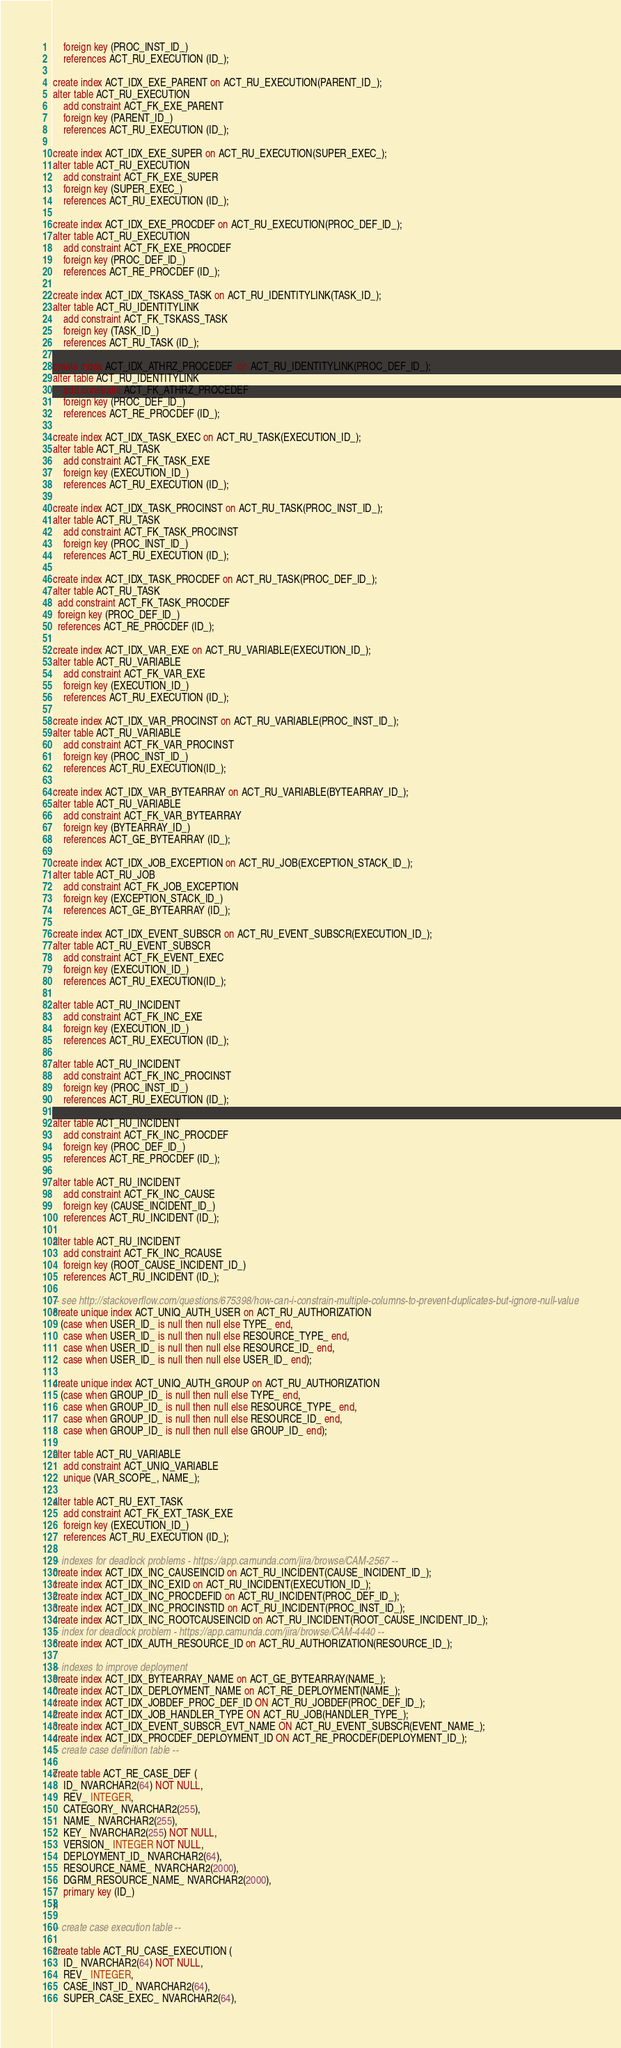Convert code to text. <code><loc_0><loc_0><loc_500><loc_500><_SQL_>    foreign key (PROC_INST_ID_) 
    references ACT_RU_EXECUTION (ID_);

create index ACT_IDX_EXE_PARENT on ACT_RU_EXECUTION(PARENT_ID_);
alter table ACT_RU_EXECUTION
    add constraint ACT_FK_EXE_PARENT
    foreign key (PARENT_ID_) 
    references ACT_RU_EXECUTION (ID_);
    
create index ACT_IDX_EXE_SUPER on ACT_RU_EXECUTION(SUPER_EXEC_);
alter table ACT_RU_EXECUTION
    add constraint ACT_FK_EXE_SUPER
    foreign key (SUPER_EXEC_) 
    references ACT_RU_EXECUTION (ID_);
    
create index ACT_IDX_EXE_PROCDEF on ACT_RU_EXECUTION(PROC_DEF_ID_);
alter table ACT_RU_EXECUTION
    add constraint ACT_FK_EXE_PROCDEF 
    foreign key (PROC_DEF_ID_) 
    references ACT_RE_PROCDEF (ID_);    

create index ACT_IDX_TSKASS_TASK on ACT_RU_IDENTITYLINK(TASK_ID_);
alter table ACT_RU_IDENTITYLINK
    add constraint ACT_FK_TSKASS_TASK
    foreign key (TASK_ID_) 
    references ACT_RU_TASK (ID_);

create index ACT_IDX_ATHRZ_PROCEDEF  on ACT_RU_IDENTITYLINK(PROC_DEF_ID_);
alter table ACT_RU_IDENTITYLINK
    add constraint ACT_FK_ATHRZ_PROCEDEF
    foreign key (PROC_DEF_ID_) 
    references ACT_RE_PROCDEF (ID_);

create index ACT_IDX_TASK_EXEC on ACT_RU_TASK(EXECUTION_ID_);
alter table ACT_RU_TASK
    add constraint ACT_FK_TASK_EXE
    foreign key (EXECUTION_ID_)
    references ACT_RU_EXECUTION (ID_);
    
create index ACT_IDX_TASK_PROCINST on ACT_RU_TASK(PROC_INST_ID_);
alter table ACT_RU_TASK
    add constraint ACT_FK_TASK_PROCINST
    foreign key (PROC_INST_ID_)
    references ACT_RU_EXECUTION (ID_);
    
create index ACT_IDX_TASK_PROCDEF on ACT_RU_TASK(PROC_DEF_ID_);
alter table ACT_RU_TASK
  add constraint ACT_FK_TASK_PROCDEF
  foreign key (PROC_DEF_ID_)
  references ACT_RE_PROCDEF (ID_);
  
create index ACT_IDX_VAR_EXE on ACT_RU_VARIABLE(EXECUTION_ID_);
alter table ACT_RU_VARIABLE 
    add constraint ACT_FK_VAR_EXE
    foreign key (EXECUTION_ID_) 
    references ACT_RU_EXECUTION (ID_);

create index ACT_IDX_VAR_PROCINST on ACT_RU_VARIABLE(PROC_INST_ID_);
alter table ACT_RU_VARIABLE
    add constraint ACT_FK_VAR_PROCINST
    foreign key (PROC_INST_ID_)
    references ACT_RU_EXECUTION(ID_);

create index ACT_IDX_VAR_BYTEARRAY on ACT_RU_VARIABLE(BYTEARRAY_ID_);
alter table ACT_RU_VARIABLE 
    add constraint ACT_FK_VAR_BYTEARRAY 
    foreign key (BYTEARRAY_ID_) 
    references ACT_GE_BYTEARRAY (ID_);

create index ACT_IDX_JOB_EXCEPTION on ACT_RU_JOB(EXCEPTION_STACK_ID_);
alter table ACT_RU_JOB 
    add constraint ACT_FK_JOB_EXCEPTION
    foreign key (EXCEPTION_STACK_ID_) 
    references ACT_GE_BYTEARRAY (ID_);
    
create index ACT_IDX_EVENT_SUBSCR on ACT_RU_EVENT_SUBSCR(EXECUTION_ID_);
alter table ACT_RU_EVENT_SUBSCR
    add constraint ACT_FK_EVENT_EXEC
    foreign key (EXECUTION_ID_)
    references ACT_RU_EXECUTION(ID_);
    
alter table ACT_RU_INCIDENT
    add constraint ACT_FK_INC_EXE 
    foreign key (EXECUTION_ID_) 
    references ACT_RU_EXECUTION (ID_);
  
alter table ACT_RU_INCIDENT
    add constraint ACT_FK_INC_PROCINST 
    foreign key (PROC_INST_ID_) 
    references ACT_RU_EXECUTION (ID_);

alter table ACT_RU_INCIDENT
    add constraint ACT_FK_INC_PROCDEF 
    foreign key (PROC_DEF_ID_) 
    references ACT_RE_PROCDEF (ID_);  
    
alter table ACT_RU_INCIDENT
    add constraint ACT_FK_INC_CAUSE 
    foreign key (CAUSE_INCIDENT_ID_) 
    references ACT_RU_INCIDENT (ID_);

alter table ACT_RU_INCIDENT
    add constraint ACT_FK_INC_RCAUSE 
    foreign key (ROOT_CAUSE_INCIDENT_ID_) 
    references ACT_RU_INCIDENT (ID_); 
    
-- see http://stackoverflow.com/questions/675398/how-can-i-constrain-multiple-columns-to-prevent-duplicates-but-ignore-null-value
create unique index ACT_UNIQ_AUTH_USER on ACT_RU_AUTHORIZATION
   (case when USER_ID_ is null then null else TYPE_ end,
    case when USER_ID_ is null then null else RESOURCE_TYPE_ end,
    case when USER_ID_ is null then null else RESOURCE_ID_ end,
    case when USER_ID_ is null then null else USER_ID_ end);

create unique index ACT_UNIQ_AUTH_GROUP on ACT_RU_AUTHORIZATION
   (case when GROUP_ID_ is null then null else TYPE_ end,
    case when GROUP_ID_ is null then null else RESOURCE_TYPE_ end,
    case when GROUP_ID_ is null then null else RESOURCE_ID_ end,
    case when GROUP_ID_ is null then null else GROUP_ID_ end);

alter table ACT_RU_VARIABLE
    add constraint ACT_UNIQ_VARIABLE
    unique (VAR_SCOPE_, NAME_);

alter table ACT_RU_EXT_TASK
    add constraint ACT_FK_EXT_TASK_EXE 
    foreign key (EXECUTION_ID_) 
    references ACT_RU_EXECUTION (ID_);

-- indexes for deadlock problems - https://app.camunda.com/jira/browse/CAM-2567 --
create index ACT_IDX_INC_CAUSEINCID on ACT_RU_INCIDENT(CAUSE_INCIDENT_ID_);
create index ACT_IDX_INC_EXID on ACT_RU_INCIDENT(EXECUTION_ID_);
create index ACT_IDX_INC_PROCDEFID on ACT_RU_INCIDENT(PROC_DEF_ID_);
create index ACT_IDX_INC_PROCINSTID on ACT_RU_INCIDENT(PROC_INST_ID_);
create index ACT_IDX_INC_ROOTCAUSEINCID on ACT_RU_INCIDENT(ROOT_CAUSE_INCIDENT_ID_);
-- index for deadlock problem - https://app.camunda.com/jira/browse/CAM-4440 --
create index ACT_IDX_AUTH_RESOURCE_ID on ACT_RU_AUTHORIZATION(RESOURCE_ID_);

-- indexes to improve deployment
create index ACT_IDX_BYTEARRAY_NAME on ACT_GE_BYTEARRAY(NAME_);
create index ACT_IDX_DEPLOYMENT_NAME on ACT_RE_DEPLOYMENT(NAME_);
create index ACT_IDX_JOBDEF_PROC_DEF_ID ON ACT_RU_JOBDEF(PROC_DEF_ID_);
create index ACT_IDX_JOB_HANDLER_TYPE ON ACT_RU_JOB(HANDLER_TYPE_);
create index ACT_IDX_EVENT_SUBSCR_EVT_NAME ON ACT_RU_EVENT_SUBSCR(EVENT_NAME_);
create index ACT_IDX_PROCDEF_DEPLOYMENT_ID ON ACT_RE_PROCDEF(DEPLOYMENT_ID_);
-- create case definition table --

create table ACT_RE_CASE_DEF (
    ID_ NVARCHAR2(64) NOT NULL,
    REV_ INTEGER,
    CATEGORY_ NVARCHAR2(255),
    NAME_ NVARCHAR2(255),
    KEY_ NVARCHAR2(255) NOT NULL,
    VERSION_ INTEGER NOT NULL,
    DEPLOYMENT_ID_ NVARCHAR2(64),
    RESOURCE_NAME_ NVARCHAR2(2000),
    DGRM_RESOURCE_NAME_ NVARCHAR2(2000),
    primary key (ID_)
);

-- create case execution table --

create table ACT_RU_CASE_EXECUTION (
    ID_ NVARCHAR2(64) NOT NULL,
    REV_ INTEGER,
    CASE_INST_ID_ NVARCHAR2(64),
    SUPER_CASE_EXEC_ NVARCHAR2(64),</code> 